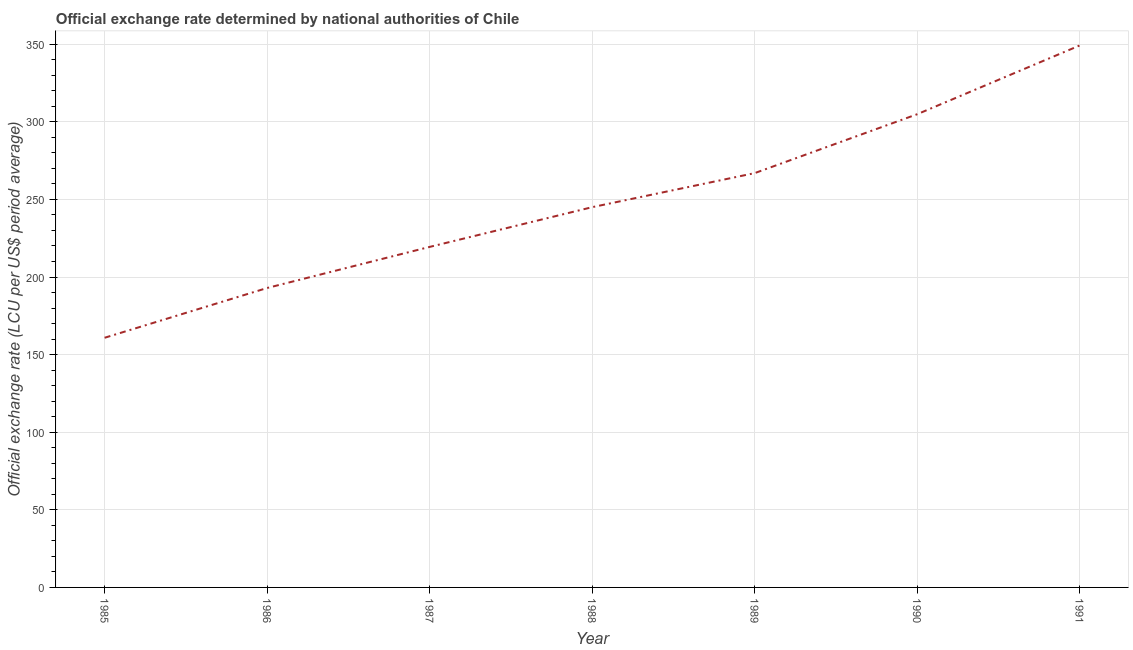What is the official exchange rate in 1985?
Provide a succinct answer. 160.86. Across all years, what is the maximum official exchange rate?
Make the answer very short. 349.22. Across all years, what is the minimum official exchange rate?
Keep it short and to the point. 160.86. In which year was the official exchange rate minimum?
Keep it short and to the point. 1985. What is the sum of the official exchange rate?
Your answer should be compact. 1739.28. What is the difference between the official exchange rate in 1987 and 1991?
Ensure brevity in your answer.  -129.81. What is the average official exchange rate per year?
Provide a short and direct response. 248.47. What is the median official exchange rate?
Give a very brief answer. 245.01. What is the ratio of the official exchange rate in 1985 to that in 1991?
Offer a terse response. 0.46. Is the difference between the official exchange rate in 1989 and 1990 greater than the difference between any two years?
Keep it short and to the point. No. What is the difference between the highest and the second highest official exchange rate?
Provide a short and direct response. 44.31. What is the difference between the highest and the lowest official exchange rate?
Give a very brief answer. 188.36. How many lines are there?
Make the answer very short. 1. How many years are there in the graph?
Give a very brief answer. 7. What is the difference between two consecutive major ticks on the Y-axis?
Offer a terse response. 50. Does the graph contain any zero values?
Make the answer very short. No. What is the title of the graph?
Your response must be concise. Official exchange rate determined by national authorities of Chile. What is the label or title of the Y-axis?
Ensure brevity in your answer.  Official exchange rate (LCU per US$ period average). What is the Official exchange rate (LCU per US$ period average) of 1985?
Offer a terse response. 160.86. What is the Official exchange rate (LCU per US$ period average) in 1986?
Make the answer very short. 192.93. What is the Official exchange rate (LCU per US$ period average) in 1987?
Your answer should be very brief. 219.41. What is the Official exchange rate (LCU per US$ period average) in 1988?
Make the answer very short. 245.01. What is the Official exchange rate (LCU per US$ period average) in 1989?
Ensure brevity in your answer.  266.95. What is the Official exchange rate (LCU per US$ period average) of 1990?
Offer a terse response. 304.9. What is the Official exchange rate (LCU per US$ period average) of 1991?
Ensure brevity in your answer.  349.22. What is the difference between the Official exchange rate (LCU per US$ period average) in 1985 and 1986?
Your answer should be very brief. -32.07. What is the difference between the Official exchange rate (LCU per US$ period average) in 1985 and 1987?
Give a very brief answer. -58.55. What is the difference between the Official exchange rate (LCU per US$ period average) in 1985 and 1988?
Give a very brief answer. -84.15. What is the difference between the Official exchange rate (LCU per US$ period average) in 1985 and 1989?
Your response must be concise. -106.09. What is the difference between the Official exchange rate (LCU per US$ period average) in 1985 and 1990?
Ensure brevity in your answer.  -144.04. What is the difference between the Official exchange rate (LCU per US$ period average) in 1985 and 1991?
Offer a terse response. -188.36. What is the difference between the Official exchange rate (LCU per US$ period average) in 1986 and 1987?
Give a very brief answer. -26.48. What is the difference between the Official exchange rate (LCU per US$ period average) in 1986 and 1988?
Ensure brevity in your answer.  -52.08. What is the difference between the Official exchange rate (LCU per US$ period average) in 1986 and 1989?
Keep it short and to the point. -74.02. What is the difference between the Official exchange rate (LCU per US$ period average) in 1986 and 1990?
Your answer should be very brief. -111.97. What is the difference between the Official exchange rate (LCU per US$ period average) in 1986 and 1991?
Give a very brief answer. -156.29. What is the difference between the Official exchange rate (LCU per US$ period average) in 1987 and 1988?
Keep it short and to the point. -25.61. What is the difference between the Official exchange rate (LCU per US$ period average) in 1987 and 1989?
Your response must be concise. -47.55. What is the difference between the Official exchange rate (LCU per US$ period average) in 1987 and 1990?
Keep it short and to the point. -85.5. What is the difference between the Official exchange rate (LCU per US$ period average) in 1987 and 1991?
Your response must be concise. -129.81. What is the difference between the Official exchange rate (LCU per US$ period average) in 1988 and 1989?
Offer a terse response. -21.94. What is the difference between the Official exchange rate (LCU per US$ period average) in 1988 and 1990?
Give a very brief answer. -59.89. What is the difference between the Official exchange rate (LCU per US$ period average) in 1988 and 1991?
Keep it short and to the point. -104.2. What is the difference between the Official exchange rate (LCU per US$ period average) in 1989 and 1990?
Make the answer very short. -37.95. What is the difference between the Official exchange rate (LCU per US$ period average) in 1989 and 1991?
Keep it short and to the point. -82.26. What is the difference between the Official exchange rate (LCU per US$ period average) in 1990 and 1991?
Give a very brief answer. -44.31. What is the ratio of the Official exchange rate (LCU per US$ period average) in 1985 to that in 1986?
Keep it short and to the point. 0.83. What is the ratio of the Official exchange rate (LCU per US$ period average) in 1985 to that in 1987?
Your answer should be very brief. 0.73. What is the ratio of the Official exchange rate (LCU per US$ period average) in 1985 to that in 1988?
Your response must be concise. 0.66. What is the ratio of the Official exchange rate (LCU per US$ period average) in 1985 to that in 1989?
Offer a very short reply. 0.6. What is the ratio of the Official exchange rate (LCU per US$ period average) in 1985 to that in 1990?
Give a very brief answer. 0.53. What is the ratio of the Official exchange rate (LCU per US$ period average) in 1985 to that in 1991?
Your answer should be very brief. 0.46. What is the ratio of the Official exchange rate (LCU per US$ period average) in 1986 to that in 1987?
Offer a very short reply. 0.88. What is the ratio of the Official exchange rate (LCU per US$ period average) in 1986 to that in 1988?
Keep it short and to the point. 0.79. What is the ratio of the Official exchange rate (LCU per US$ period average) in 1986 to that in 1989?
Provide a short and direct response. 0.72. What is the ratio of the Official exchange rate (LCU per US$ period average) in 1986 to that in 1990?
Your answer should be compact. 0.63. What is the ratio of the Official exchange rate (LCU per US$ period average) in 1986 to that in 1991?
Keep it short and to the point. 0.55. What is the ratio of the Official exchange rate (LCU per US$ period average) in 1987 to that in 1988?
Offer a very short reply. 0.9. What is the ratio of the Official exchange rate (LCU per US$ period average) in 1987 to that in 1989?
Your answer should be very brief. 0.82. What is the ratio of the Official exchange rate (LCU per US$ period average) in 1987 to that in 1990?
Keep it short and to the point. 0.72. What is the ratio of the Official exchange rate (LCU per US$ period average) in 1987 to that in 1991?
Your answer should be compact. 0.63. What is the ratio of the Official exchange rate (LCU per US$ period average) in 1988 to that in 1989?
Give a very brief answer. 0.92. What is the ratio of the Official exchange rate (LCU per US$ period average) in 1988 to that in 1990?
Give a very brief answer. 0.8. What is the ratio of the Official exchange rate (LCU per US$ period average) in 1988 to that in 1991?
Provide a succinct answer. 0.7. What is the ratio of the Official exchange rate (LCU per US$ period average) in 1989 to that in 1990?
Give a very brief answer. 0.88. What is the ratio of the Official exchange rate (LCU per US$ period average) in 1989 to that in 1991?
Provide a succinct answer. 0.76. What is the ratio of the Official exchange rate (LCU per US$ period average) in 1990 to that in 1991?
Provide a succinct answer. 0.87. 